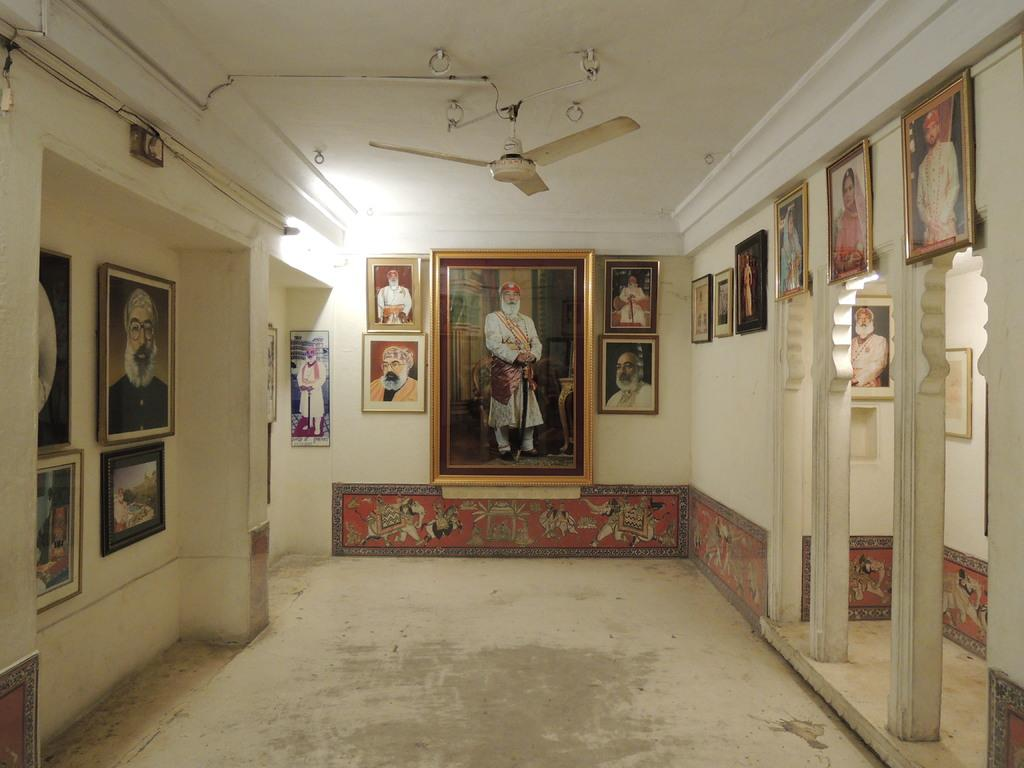What can be seen on the walls in the image? There are many photo frames attached to the walls in the image. What architectural features are present on the right side of the image? There are three pillars on the right side of the image. Are there any photo frames behind the pillars? Yes, there are two frames attached to the walls behind the pillars. What type of cushion is being used as a scene prop in the image? There is no cushion or scene present in the image; it features photo frames on the walls and pillars. What color is the glove that is hanging on the wall in the image? There is no glove present in the image. 